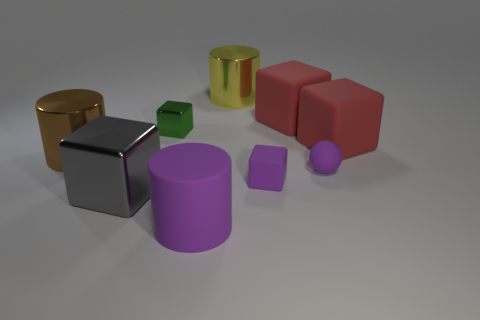Subtract all red cubes. How many cubes are left? 3 Subtract all purple matte cylinders. How many cylinders are left? 2 Subtract all spheres. How many objects are left? 8 Add 7 big purple things. How many big purple things are left? 8 Add 7 purple matte cylinders. How many purple matte cylinders exist? 8 Subtract 0 red cylinders. How many objects are left? 9 Subtract 3 cubes. How many cubes are left? 2 Subtract all gray cylinders. Subtract all blue balls. How many cylinders are left? 3 Subtract all gray balls. How many purple cylinders are left? 1 Subtract all large shiny blocks. Subtract all small balls. How many objects are left? 7 